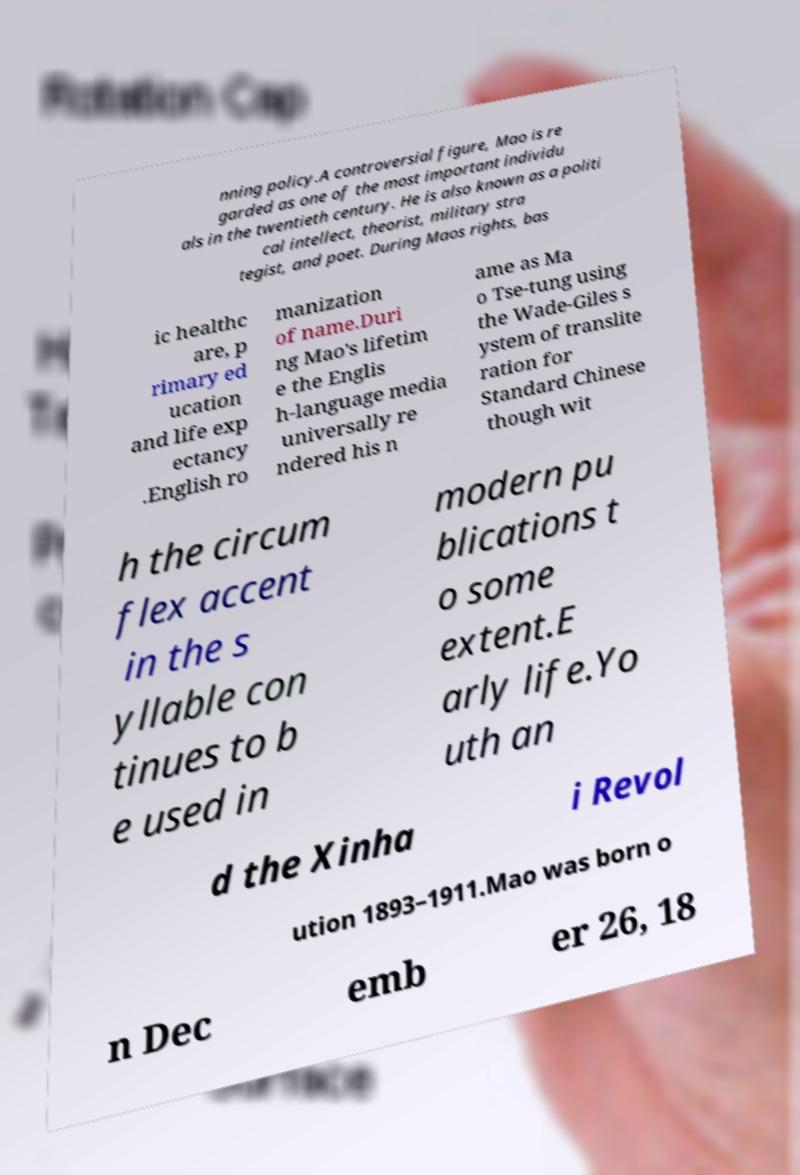What messages or text are displayed in this image? I need them in a readable, typed format. nning policy.A controversial figure, Mao is re garded as one of the most important individu als in the twentieth century. He is also known as a politi cal intellect, theorist, military stra tegist, and poet. During Maos rights, bas ic healthc are, p rimary ed ucation and life exp ectancy .English ro manization of name.Duri ng Mao's lifetim e the Englis h-language media universally re ndered his n ame as Ma o Tse-tung using the Wade-Giles s ystem of translite ration for Standard Chinese though wit h the circum flex accent in the s yllable con tinues to b e used in modern pu blications t o some extent.E arly life.Yo uth an d the Xinha i Revol ution 1893–1911.Mao was born o n Dec emb er 26, 18 